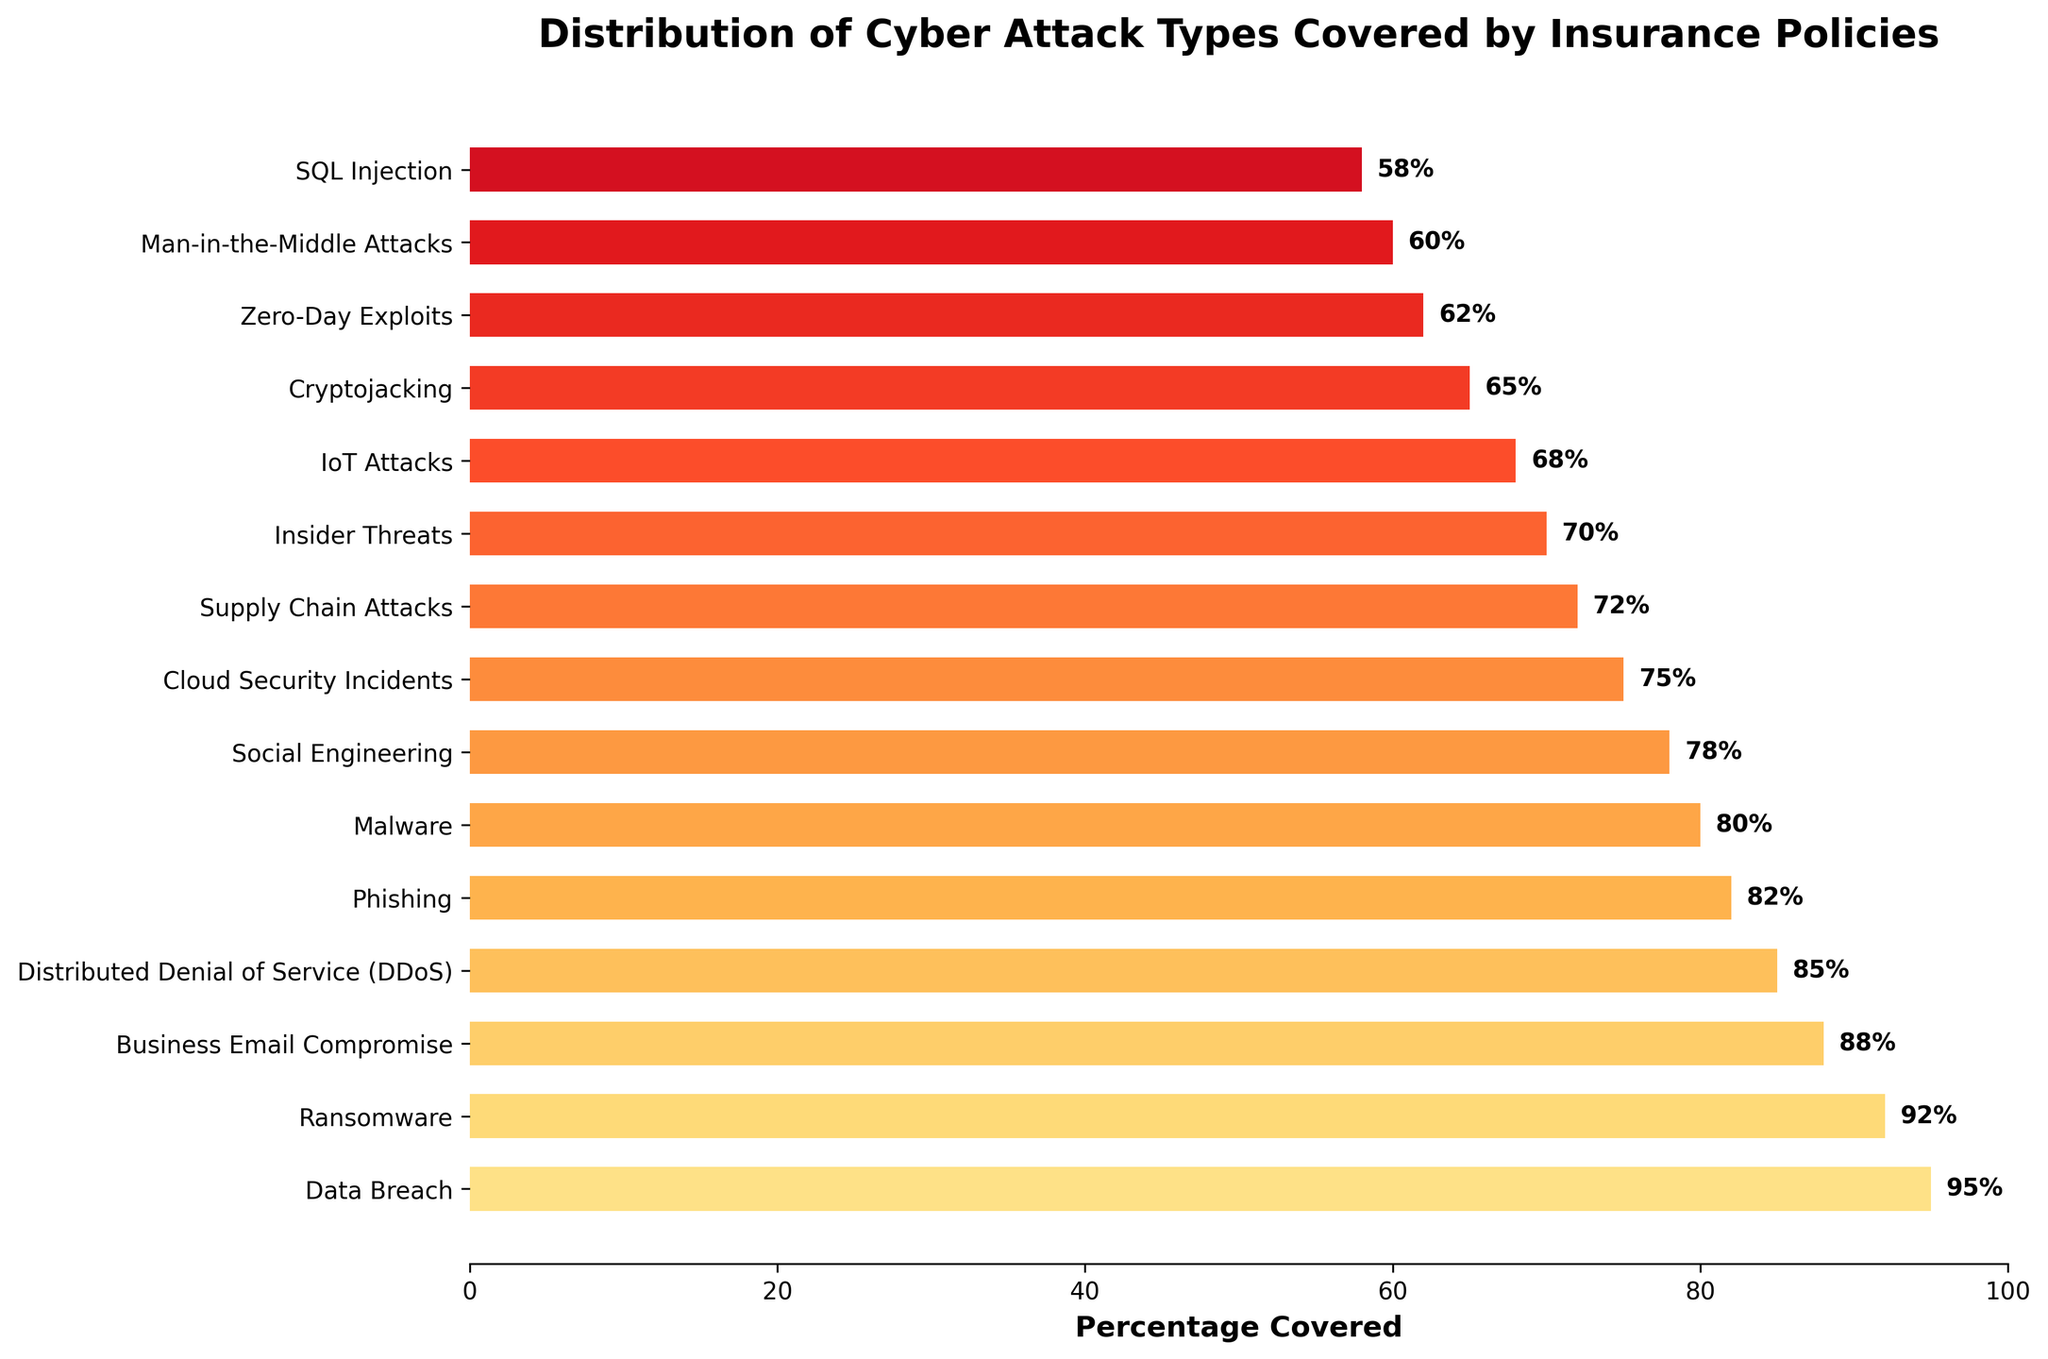Which cyber attack type has the highest percentage of coverage? By looking at the height of the bars, the tallest bar corresponds to Data Breach, which has the highest percentage coverage.
Answer: Data Breach Which cyber attack type has the lowest percentage of coverage? By checking the shortest bar, the lowest percentage coverage is for SQL Injection, shown by the last bar.
Answer: SQL Injection What is the total percentage of coverage for Business Email Compromise and Cloud Security Incidents combined? The percentage coverage for Business Email Compromise is 88% and for Cloud Security Incidents is 75%. Adding these gives 88 + 75 = 163%.
Answer: 163% Which cyber attack type has a higher coverage: Phishing or Malware? Comparing the lengths of the bars for Phishing and Malware, Phishing has a higher percentage coverage at 82%, while Malware has 80%.
Answer: Phishing Are there any cyber attack types with a coverage percentage of less than 70%? If so, which ones? By examining all bars with coverage percentages less than 70%, there are four: IoT Attacks (68%), Cryptojacking (65%), Zero-Day Exploits (62%), and SQL Injection (58%).
Answer: IoT Attacks, Cryptojacking, Zero-Day Exploits, and SQL Injection What is the difference in coverage between Ransomware and Insider Threats? The percentage coverage for Ransomware is 92% and for Insider Threats is 70%. Subtracting these, 92 - 70 = 22%.
Answer: 22% Which cyber attack types have a coverage percentage greater than 85%? The bars to the right of the 85% mark correspond to Data Breach (95%), Ransomware (92%), Business Email Compromise (88%), and Distributed Denial of Service (DDoS) (85%).
Answer: Data Breach, Ransomware, Business Email Compromise, and DDoS What is the median percentage coverage among all the cyber attack types? To find the median, the percentages need to be ordered: 58%, 60%, 62%, 65%, 68%, 70%, 72%, 75%, 78%, 80%, 82%, 85%, 88%, 92%, 95%. The median is the middle value in this ordered list, which is 75%.
Answer: 75% How many cyber attack types have a coverage percentage of at least 80%? By counting the bars that meet or exceed the 80% mark, there are six: Data Breach (95%), Ransomware (92%), Business Email Compromise (88%), Distributed Denial of Service (DDoS) (85%), Phishing (82%), and Malware (80%).
Answer: 6 